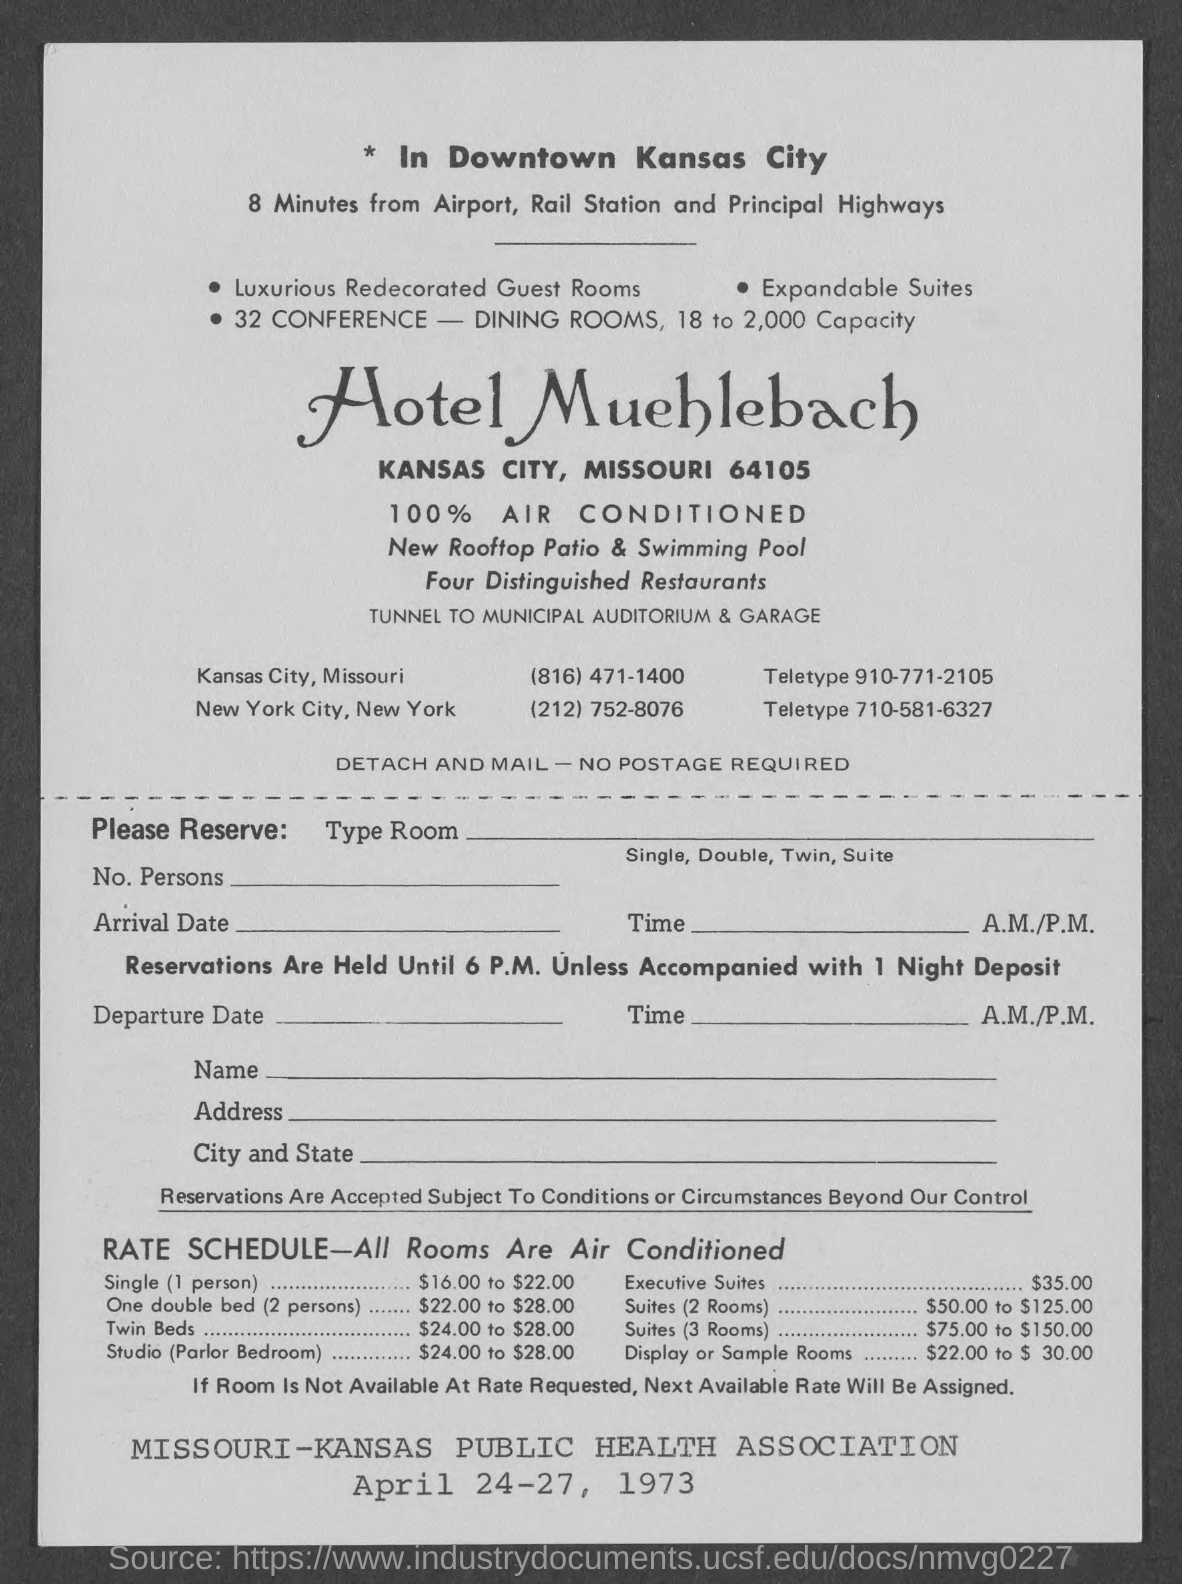Which hotel is mentioned?
Make the answer very short. Hotel Muehlebach. In which part of Kansas City is the hotel located?
Provide a succinct answer. Downtown. How far is the hotel from Airport, Rail Station and Principal Highways?
Your response must be concise. 8 minutes. What are the new additions?
Provide a short and direct response. Rooftop Patio & Swimming Pool. How many distinguished restaurants are there?
Offer a terse response. Four. What is the teletype number of Kansas City hotel?
Provide a succinct answer. 910-771-2105. When is the document dated?
Offer a very short reply. April 24-27, 1973. 